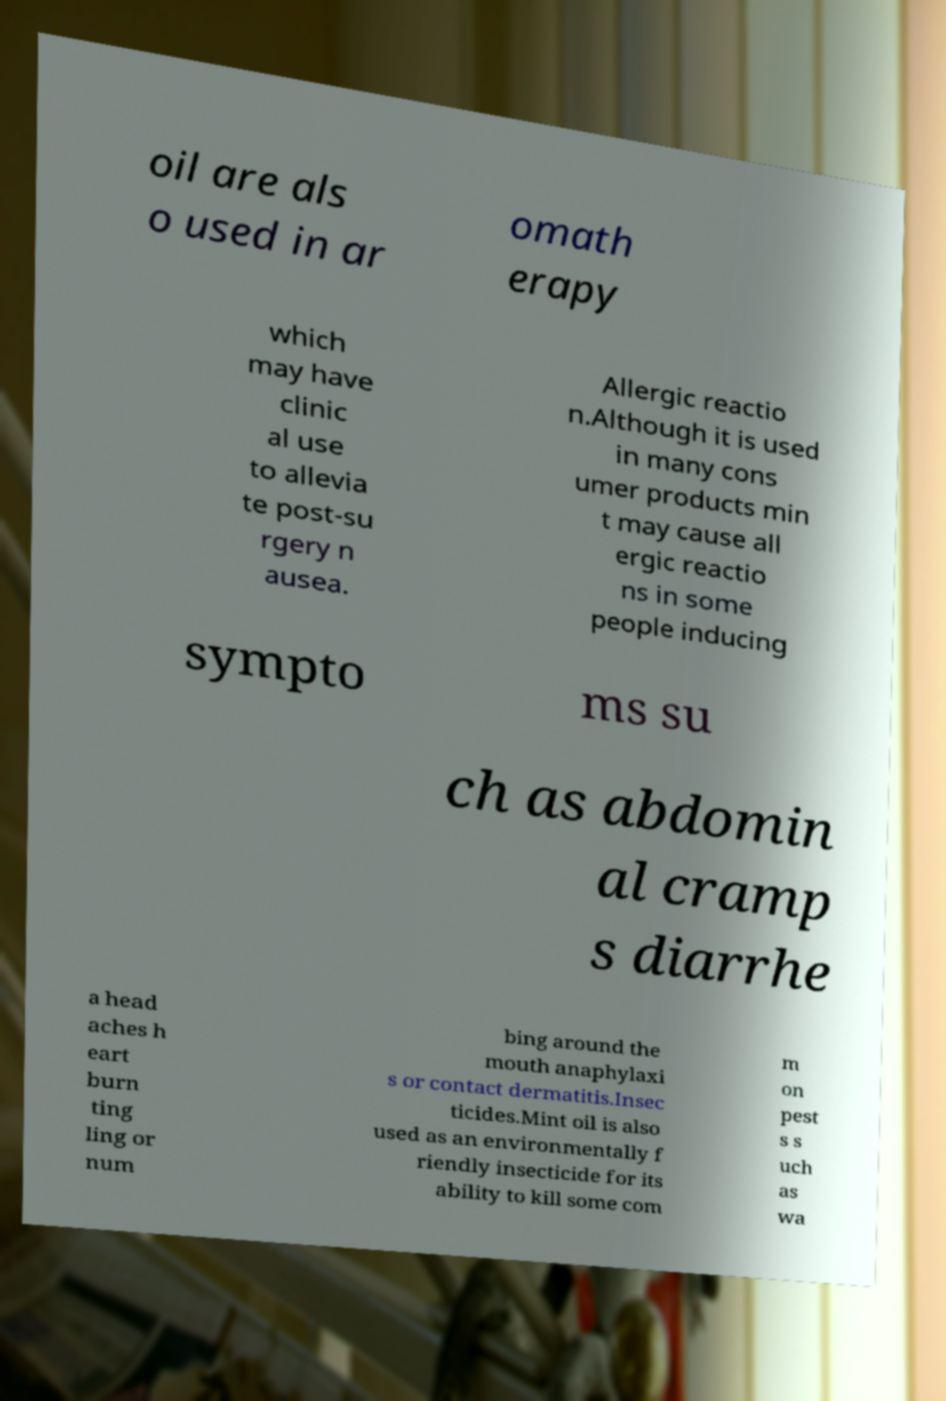Can you accurately transcribe the text from the provided image for me? oil are als o used in ar omath erapy which may have clinic al use to allevia te post-su rgery n ausea. Allergic reactio n.Although it is used in many cons umer products min t may cause all ergic reactio ns in some people inducing sympto ms su ch as abdomin al cramp s diarrhe a head aches h eart burn ting ling or num bing around the mouth anaphylaxi s or contact dermatitis.Insec ticides.Mint oil is also used as an environmentally f riendly insecticide for its ability to kill some com m on pest s s uch as wa 